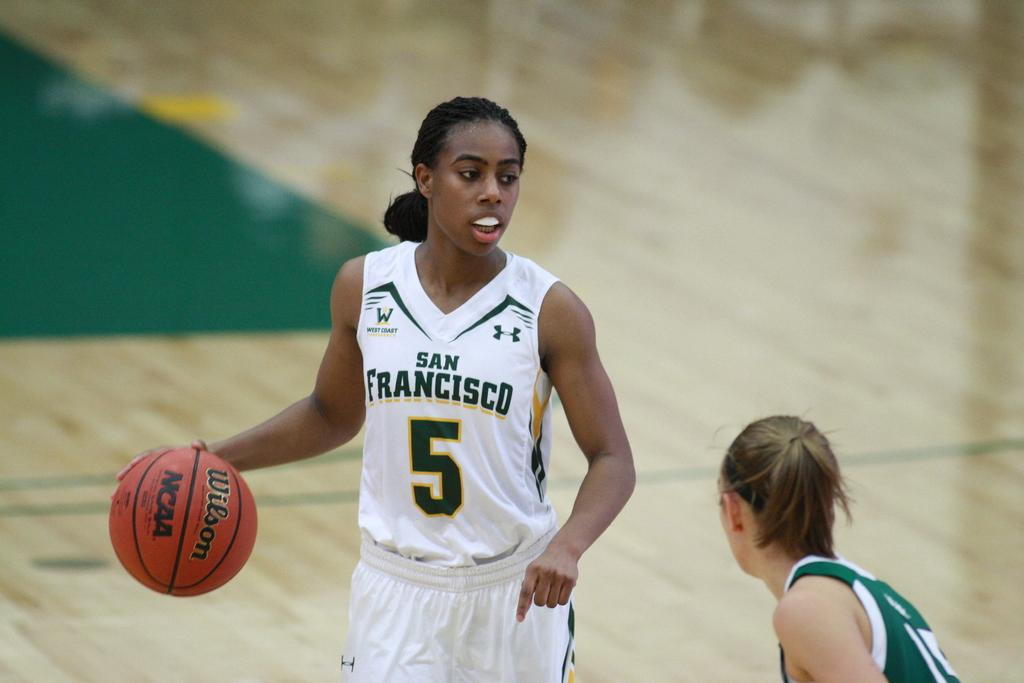<image>
Write a terse but informative summary of the picture. Player number 5 for San Francisco has the ball. 